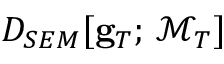Convert formula to latex. <formula><loc_0><loc_0><loc_500><loc_500>D _ { S E M } [ { g } _ { T } ; \, \mathcal { M } _ { T } ]</formula> 